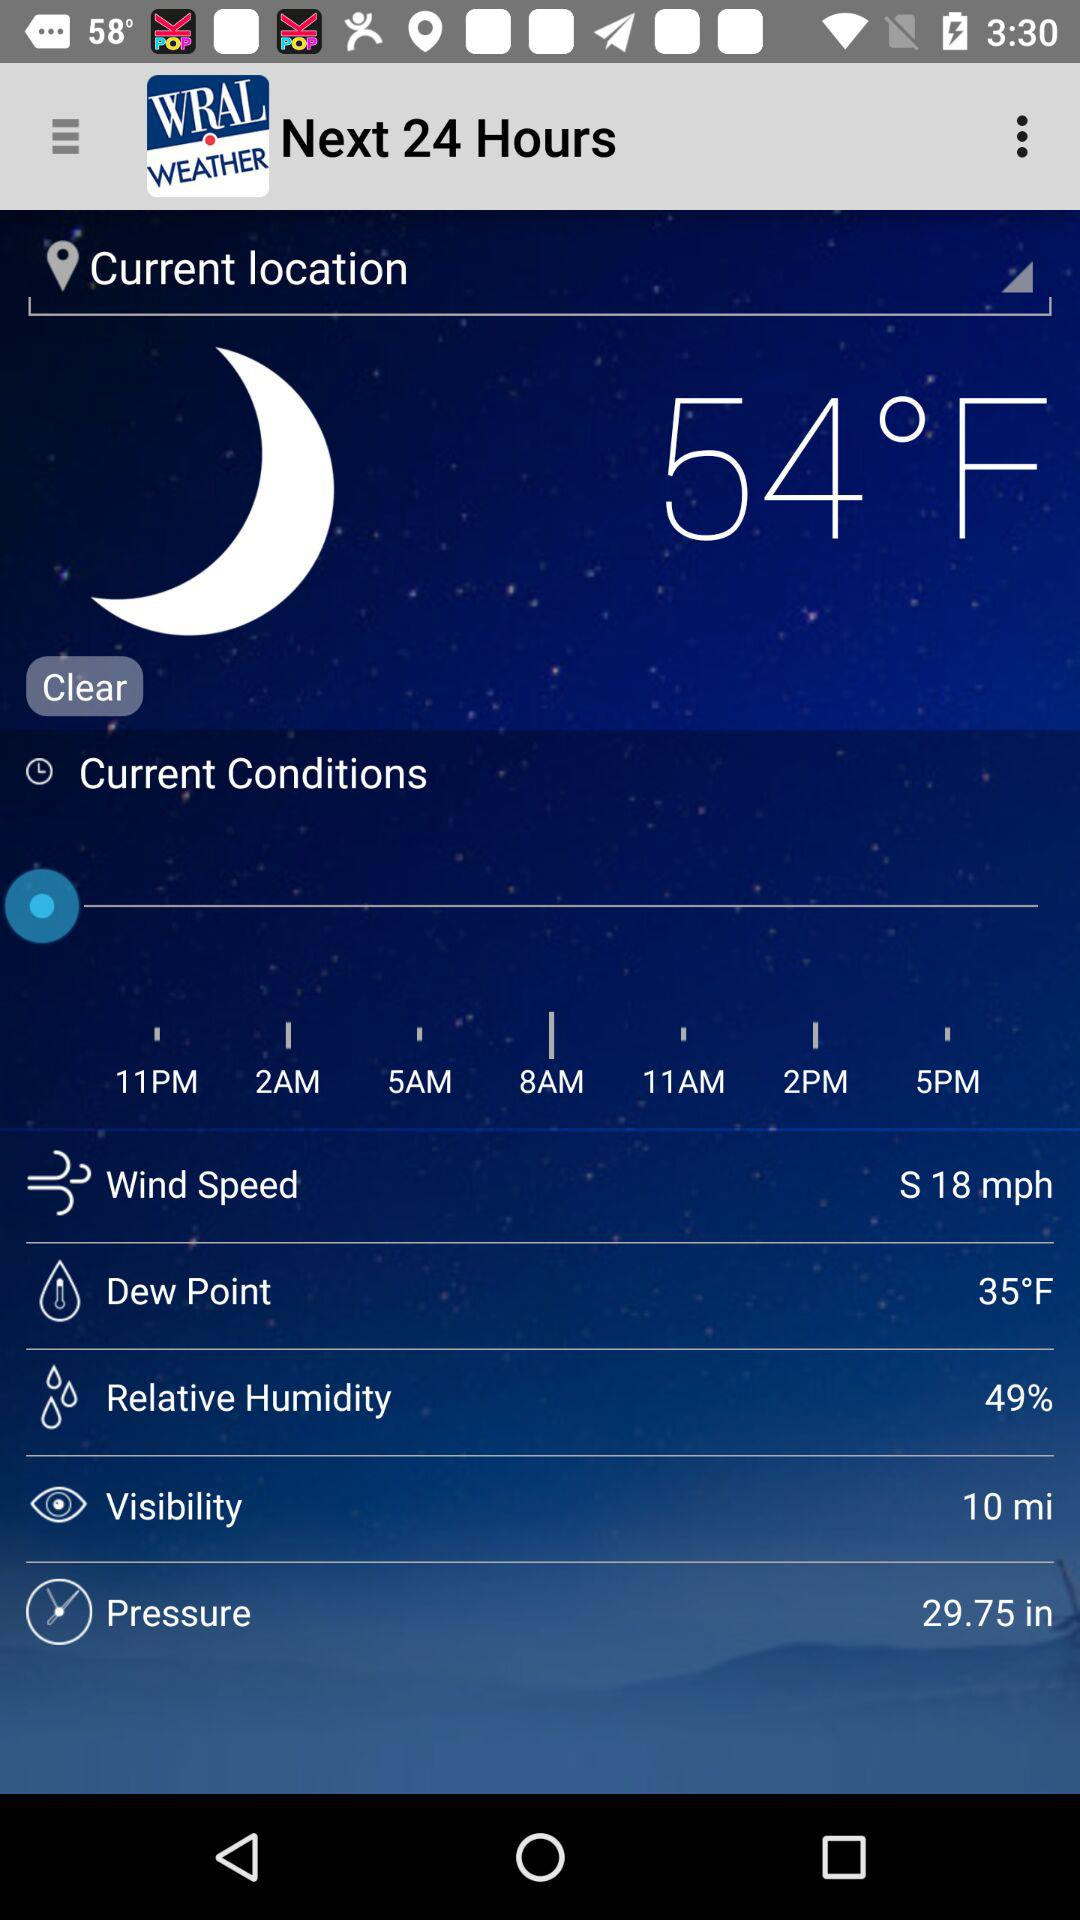What is the wind speed? The wind speed is 18 mph. 